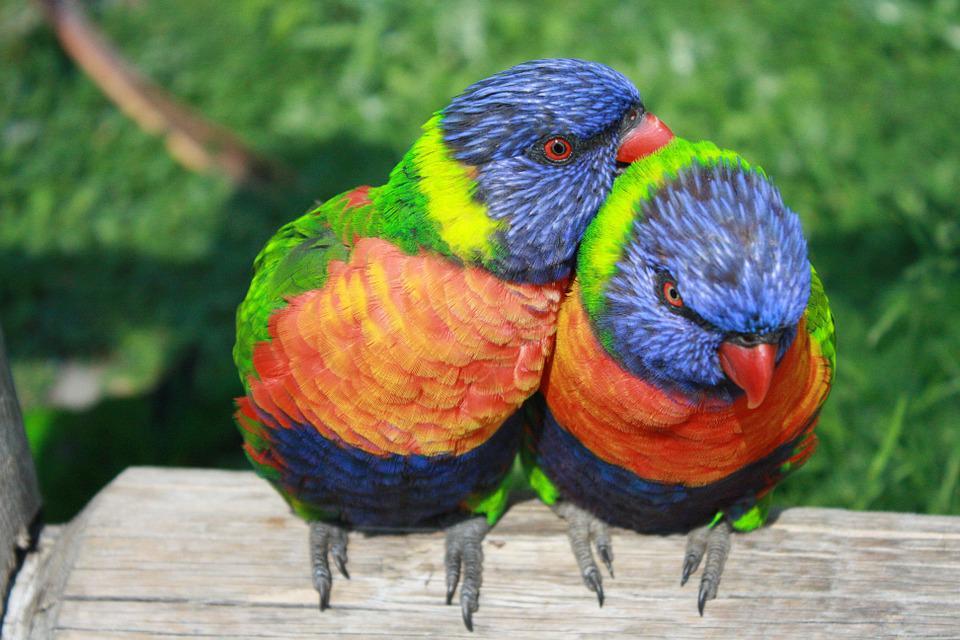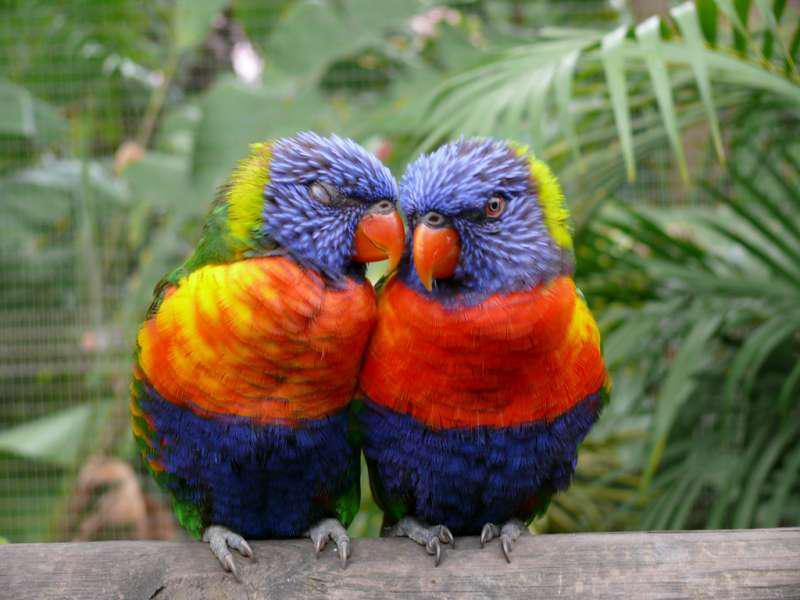The first image is the image on the left, the second image is the image on the right. Considering the images on both sides, is "There are three parrots." valid? Answer yes or no. No. The first image is the image on the left, the second image is the image on the right. For the images displayed, is the sentence "There are four colorful birds in the pair of images." factually correct? Answer yes or no. Yes. 